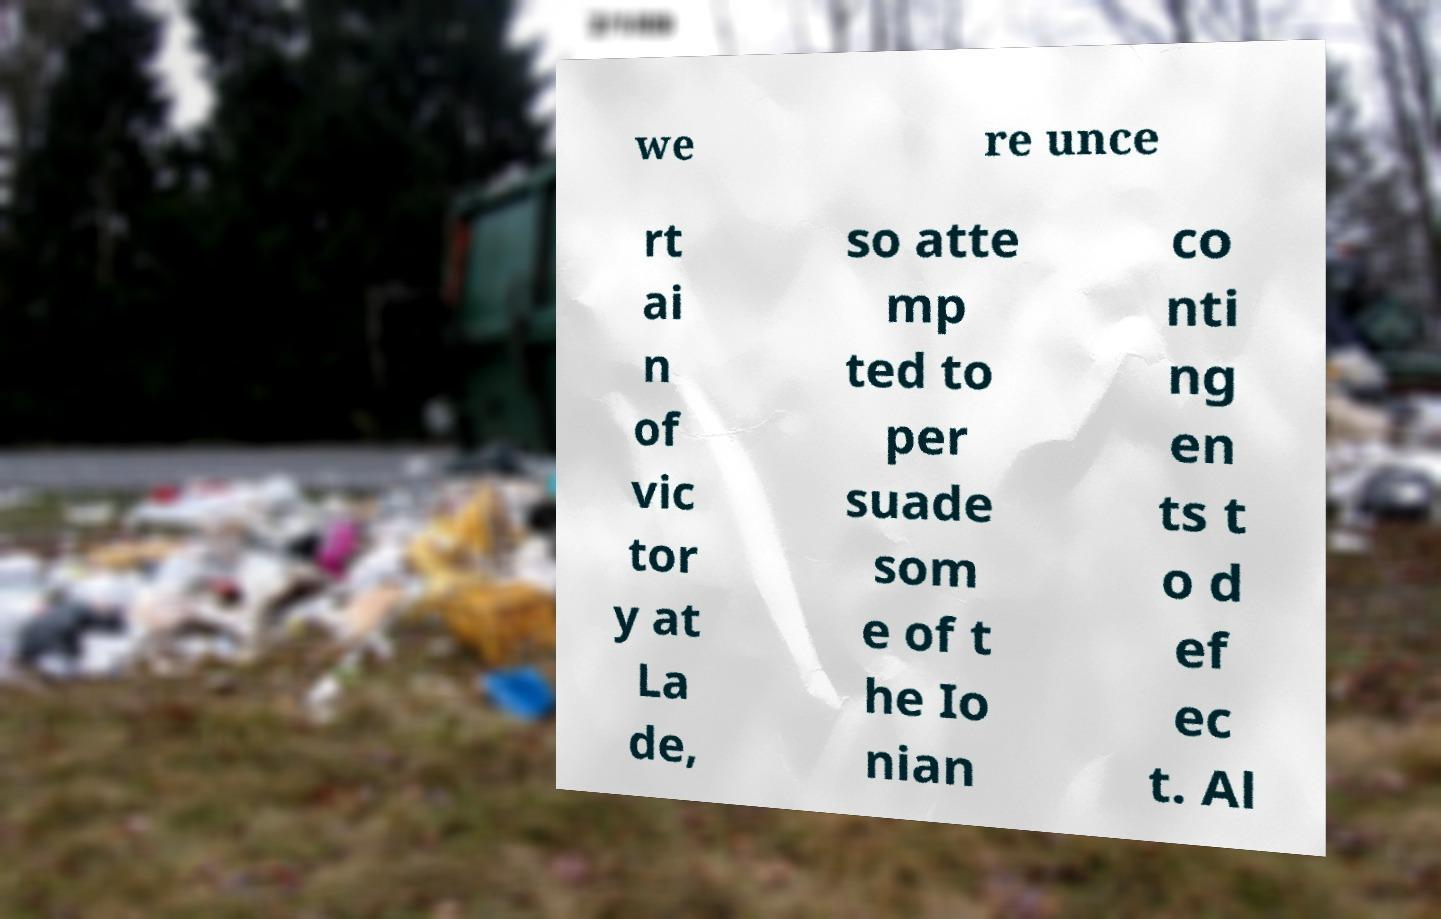Can you accurately transcribe the text from the provided image for me? we re unce rt ai n of vic tor y at La de, so atte mp ted to per suade som e of t he Io nian co nti ng en ts t o d ef ec t. Al 